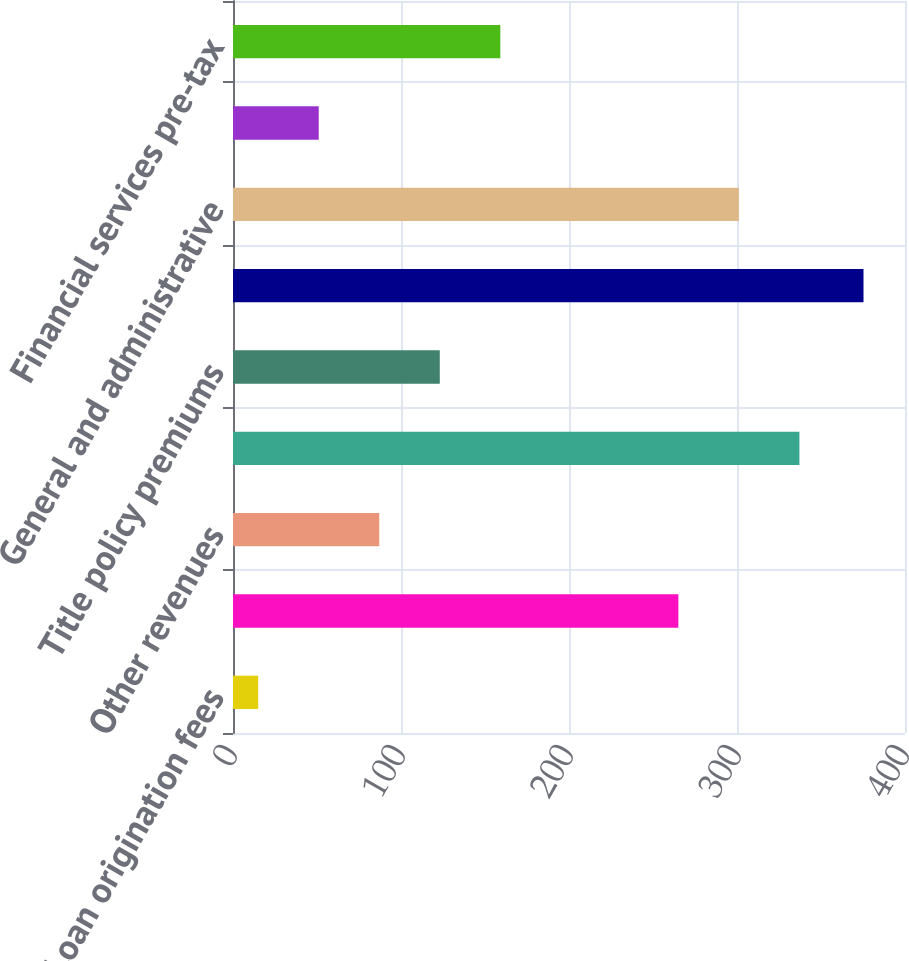<chart> <loc_0><loc_0><loc_500><loc_500><bar_chart><fcel>Loan origination fees<fcel>Sale of servicing rights and<fcel>Other revenues<fcel>Total mortgage operations<fcel>Title policy premiums<fcel>Total revenues<fcel>General and administrative<fcel>Other (income) expense<fcel>Financial services pre-tax<nl><fcel>15<fcel>265.1<fcel>87.06<fcel>337.16<fcel>123.09<fcel>375.3<fcel>301.13<fcel>51.03<fcel>159.12<nl></chart> 